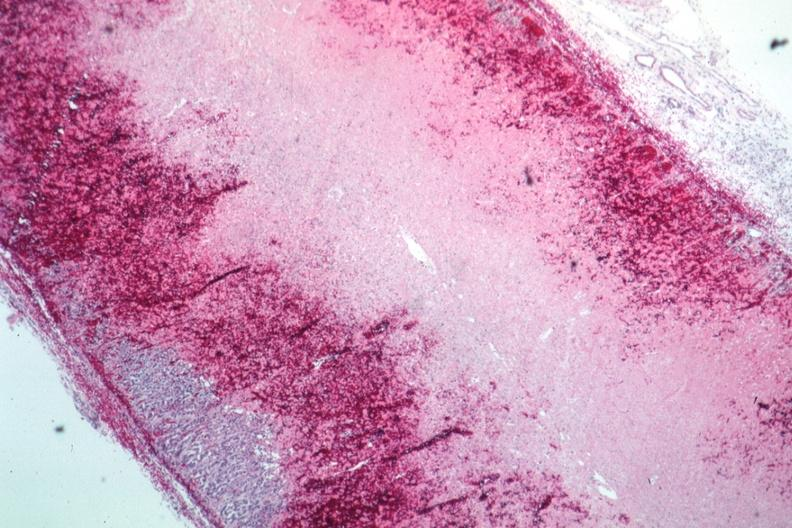what is present?
Answer the question using a single word or phrase. Endocrine 